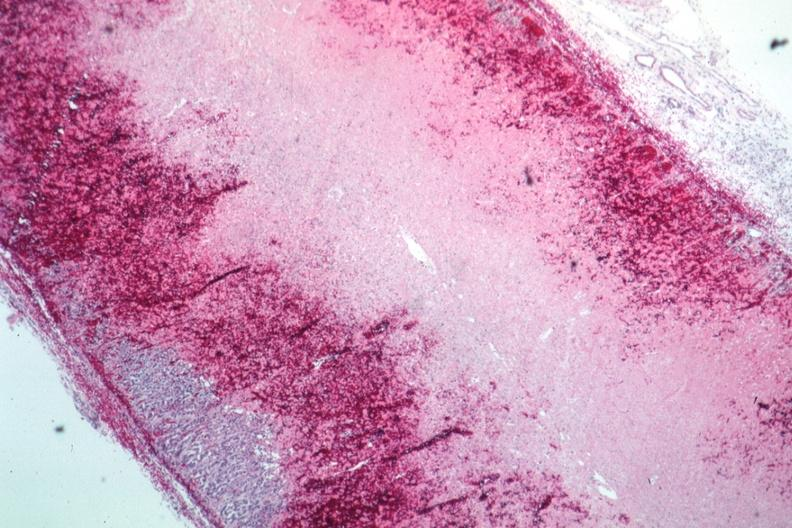what is present?
Answer the question using a single word or phrase. Endocrine 